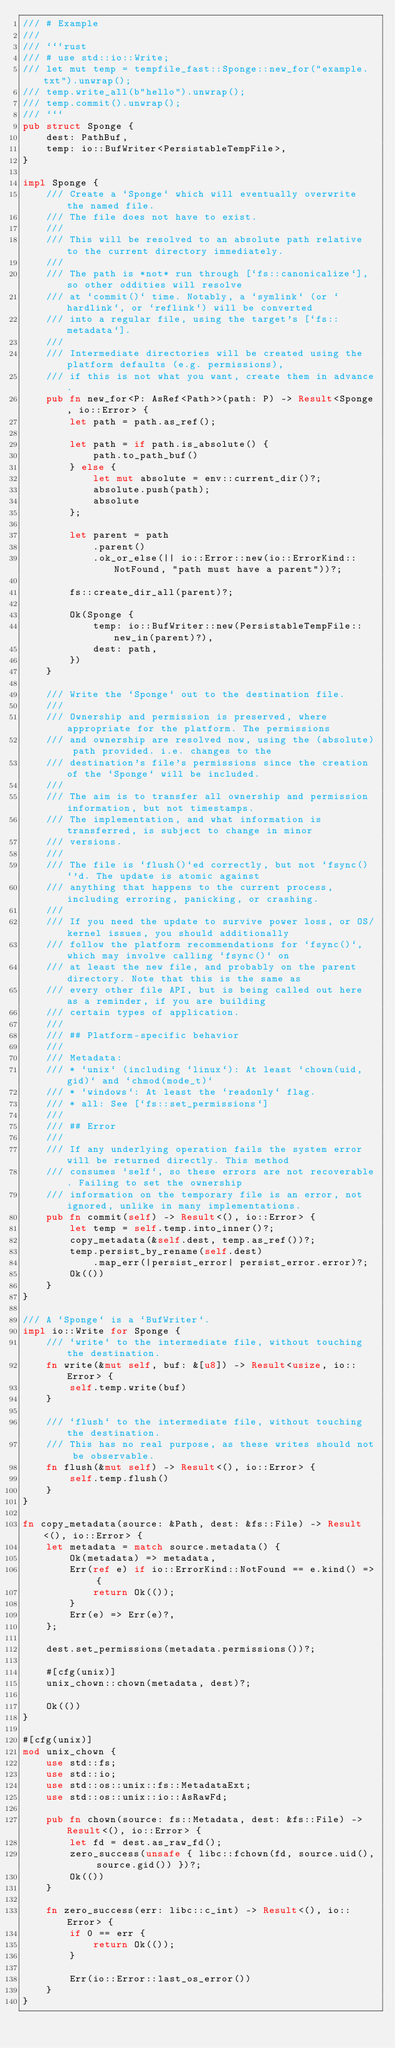<code> <loc_0><loc_0><loc_500><loc_500><_Rust_>/// # Example
///
/// ```rust
/// # use std::io::Write;
/// let mut temp = tempfile_fast::Sponge::new_for("example.txt").unwrap();
/// temp.write_all(b"hello").unwrap();
/// temp.commit().unwrap();
/// ```
pub struct Sponge {
    dest: PathBuf,
    temp: io::BufWriter<PersistableTempFile>,
}

impl Sponge {
    /// Create a `Sponge` which will eventually overwrite the named file.
    /// The file does not have to exist.
    ///
    /// This will be resolved to an absolute path relative to the current directory immediately.
    ///
    /// The path is *not* run through [`fs::canonicalize`], so other oddities will resolve
    /// at `commit()` time. Notably, a `symlink` (or `hardlink`, or `reflink`) will be converted
    /// into a regular file, using the target's [`fs::metadata`].
    ///
    /// Intermediate directories will be created using the platform defaults (e.g. permissions),
    /// if this is not what you want, create them in advance.
    pub fn new_for<P: AsRef<Path>>(path: P) -> Result<Sponge, io::Error> {
        let path = path.as_ref();

        let path = if path.is_absolute() {
            path.to_path_buf()
        } else {
            let mut absolute = env::current_dir()?;
            absolute.push(path);
            absolute
        };

        let parent = path
            .parent()
            .ok_or_else(|| io::Error::new(io::ErrorKind::NotFound, "path must have a parent"))?;

        fs::create_dir_all(parent)?;

        Ok(Sponge {
            temp: io::BufWriter::new(PersistableTempFile::new_in(parent)?),
            dest: path,
        })
    }

    /// Write the `Sponge` out to the destination file.
    ///
    /// Ownership and permission is preserved, where appropriate for the platform. The permissions
    /// and ownership are resolved now, using the (absolute) path provided. i.e. changes to the
    /// destination's file's permissions since the creation of the `Sponge` will be included.
    ///
    /// The aim is to transfer all ownership and permission information, but not timestamps.
    /// The implementation, and what information is transferred, is subject to change in minor
    /// versions.
    ///
    /// The file is `flush()`ed correctly, but not `fsync()`'d. The update is atomic against
    /// anything that happens to the current process, including erroring, panicking, or crashing.
    ///
    /// If you need the update to survive power loss, or OS/kernel issues, you should additionally
    /// follow the platform recommendations for `fsync()`, which may involve calling `fsync()` on
    /// at least the new file, and probably on the parent directory. Note that this is the same as
    /// every other file API, but is being called out here as a reminder, if you are building
    /// certain types of application.
    ///
    /// ## Platform-specific behavior
    ///
    /// Metadata:
    /// * `unix` (including `linux`): At least `chown(uid, gid)` and `chmod(mode_t)`
    /// * `windows`: At least the `readonly` flag.
    /// * all: See [`fs::set_permissions`]
    ///
    /// ## Error
    ///
    /// If any underlying operation fails the system error will be returned directly. This method
    /// consumes `self`, so these errors are not recoverable. Failing to set the ownership
    /// information on the temporary file is an error, not ignored, unlike in many implementations.
    pub fn commit(self) -> Result<(), io::Error> {
        let temp = self.temp.into_inner()?;
        copy_metadata(&self.dest, temp.as_ref())?;
        temp.persist_by_rename(self.dest)
            .map_err(|persist_error| persist_error.error)?;
        Ok(())
    }
}

/// A `Sponge` is a `BufWriter`.
impl io::Write for Sponge {
    /// `write` to the intermediate file, without touching the destination.
    fn write(&mut self, buf: &[u8]) -> Result<usize, io::Error> {
        self.temp.write(buf)
    }

    /// `flush` to the intermediate file, without touching the destination.
    /// This has no real purpose, as these writes should not be observable.
    fn flush(&mut self) -> Result<(), io::Error> {
        self.temp.flush()
    }
}

fn copy_metadata(source: &Path, dest: &fs::File) -> Result<(), io::Error> {
    let metadata = match source.metadata() {
        Ok(metadata) => metadata,
        Err(ref e) if io::ErrorKind::NotFound == e.kind() => {
            return Ok(());
        }
        Err(e) => Err(e)?,
    };

    dest.set_permissions(metadata.permissions())?;

    #[cfg(unix)]
    unix_chown::chown(metadata, dest)?;

    Ok(())
}

#[cfg(unix)]
mod unix_chown {
    use std::fs;
    use std::io;
    use std::os::unix::fs::MetadataExt;
    use std::os::unix::io::AsRawFd;

    pub fn chown(source: fs::Metadata, dest: &fs::File) -> Result<(), io::Error> {
        let fd = dest.as_raw_fd();
        zero_success(unsafe { libc::fchown(fd, source.uid(), source.gid()) })?;
        Ok(())
    }

    fn zero_success(err: libc::c_int) -> Result<(), io::Error> {
        if 0 == err {
            return Ok(());
        }

        Err(io::Error::last_os_error())
    }
}
</code> 